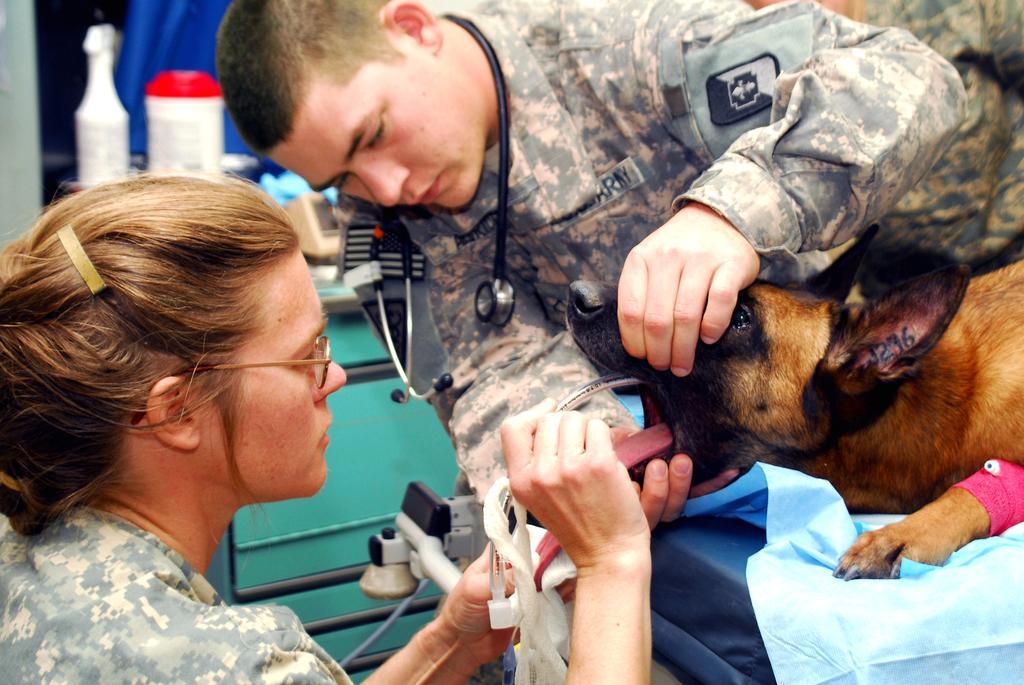Describe this image in one or two sentences. In this image there are two persons and a dog which is on the bed and the lady person treating the dog. At the background of the image there is a person holding dog. 